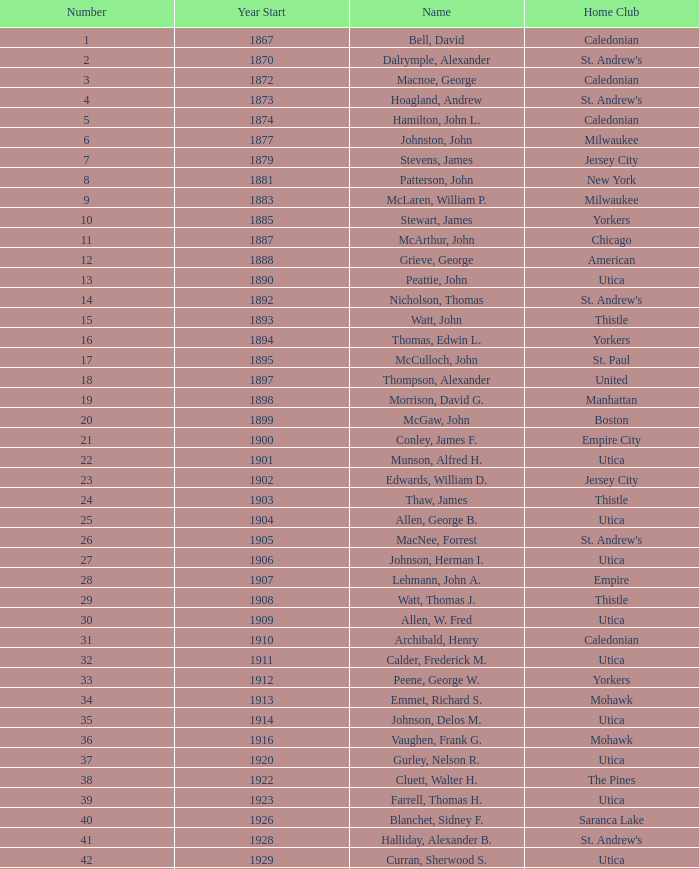Which Number has a Name of hill, lucius t.? 53.0. 